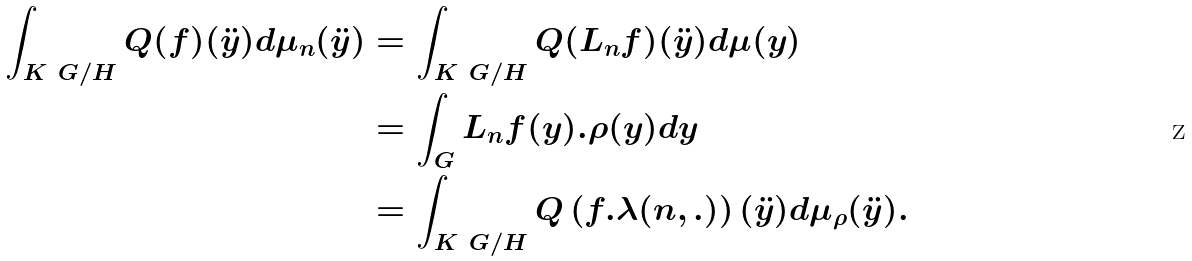Convert formula to latex. <formula><loc_0><loc_0><loc_500><loc_500>\int _ { K \ G / H } Q ( f ) ( \ddot { y } ) d \mu _ { n } ( \ddot { y } ) & = \int _ { K \ G / H } Q ( L _ { n } f ) ( \ddot { y } ) d \mu ( y ) \\ & = \int _ { G } L _ { n } f ( y ) . \rho ( y ) d y \\ & = \int _ { K \ G / H } Q \left ( f . \lambda ( n , . ) \right ) ( \ddot { y } ) d \mu _ { \rho } ( \ddot { y } ) .</formula> 